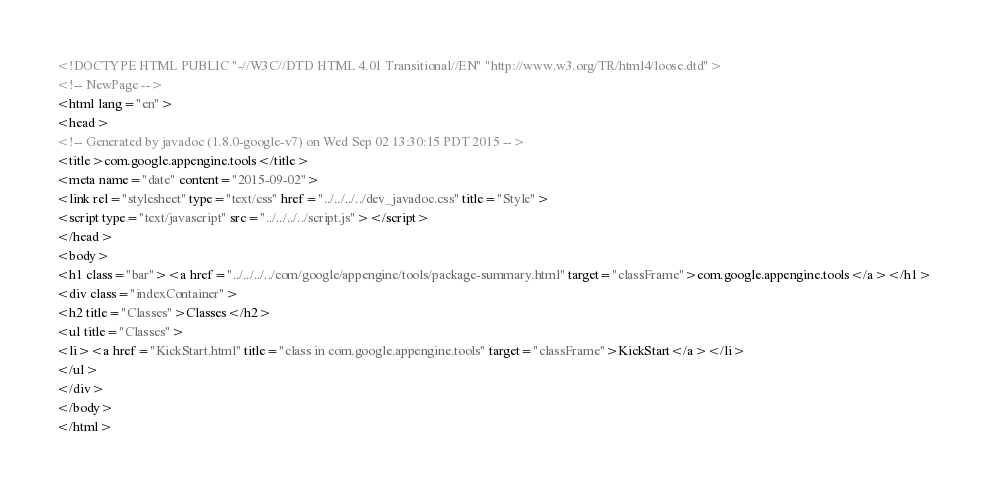<code> <loc_0><loc_0><loc_500><loc_500><_HTML_><!DOCTYPE HTML PUBLIC "-//W3C//DTD HTML 4.01 Transitional//EN" "http://www.w3.org/TR/html4/loose.dtd">
<!-- NewPage -->
<html lang="en">
<head>
<!-- Generated by javadoc (1.8.0-google-v7) on Wed Sep 02 13:30:15 PDT 2015 -->
<title>com.google.appengine.tools</title>
<meta name="date" content="2015-09-02">
<link rel="stylesheet" type="text/css" href="../../../../dev_javadoc.css" title="Style">
<script type="text/javascript" src="../../../../script.js"></script>
</head>
<body>
<h1 class="bar"><a href="../../../../com/google/appengine/tools/package-summary.html" target="classFrame">com.google.appengine.tools</a></h1>
<div class="indexContainer">
<h2 title="Classes">Classes</h2>
<ul title="Classes">
<li><a href="KickStart.html" title="class in com.google.appengine.tools" target="classFrame">KickStart</a></li>
</ul>
</div>
</body>
</html>
</code> 